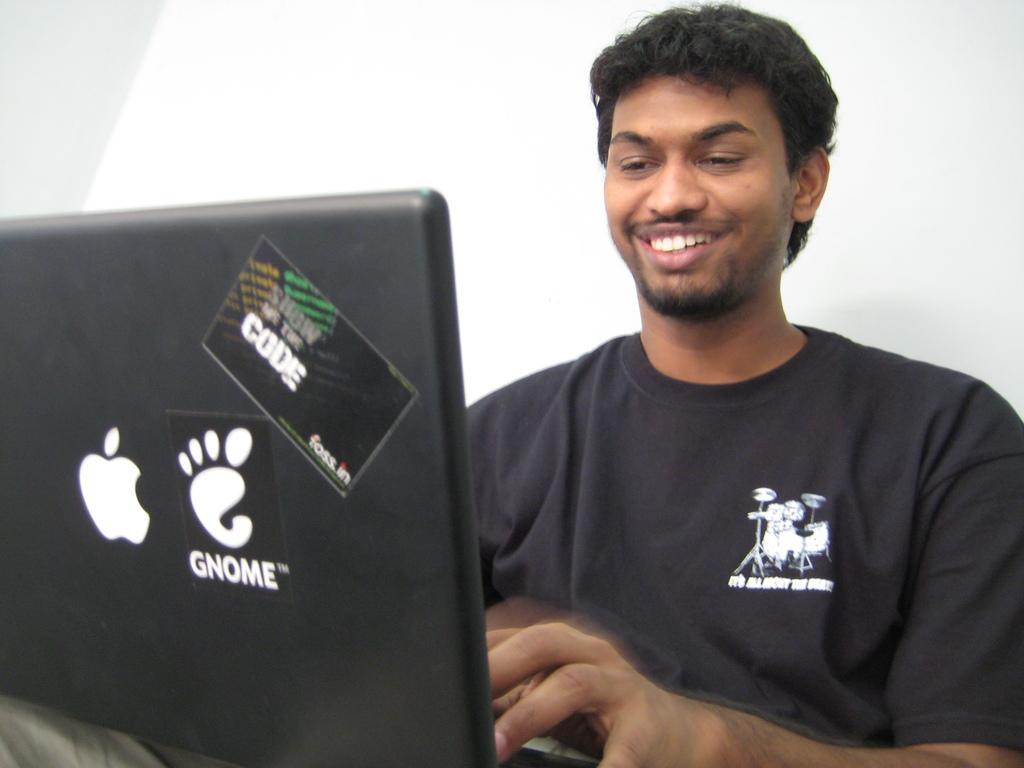Describe this image in one or two sentences. In this image we can see a man. He is wearing a black color T-shirt and light brown pant. In front of him, there is a black color laptop. There is a white wall in the background of the image. 